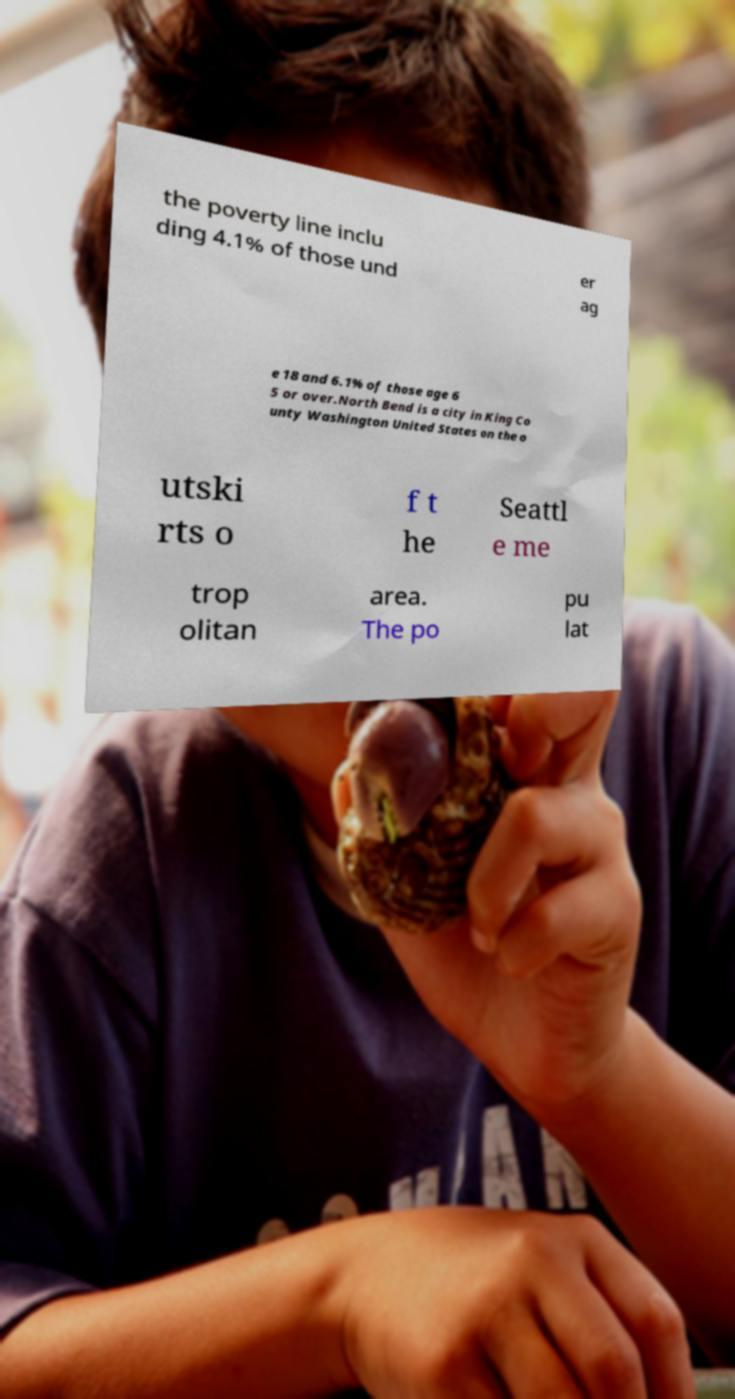Please read and relay the text visible in this image. What does it say? the poverty line inclu ding 4.1% of those und er ag e 18 and 6.1% of those age 6 5 or over.North Bend is a city in King Co unty Washington United States on the o utski rts o f t he Seattl e me trop olitan area. The po pu lat 